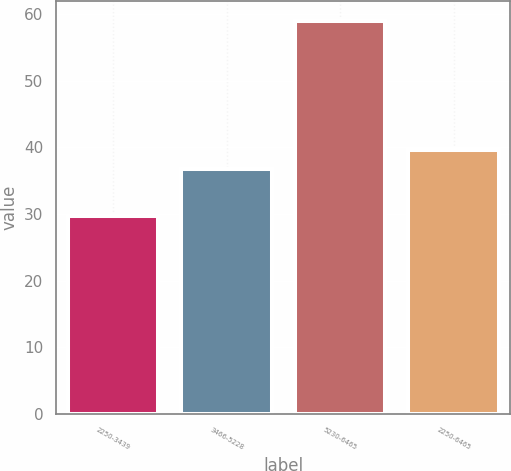Convert chart to OTSL. <chart><loc_0><loc_0><loc_500><loc_500><bar_chart><fcel>2250-3439<fcel>3466-5228<fcel>5230-6465<fcel>2250-6465<nl><fcel>29.64<fcel>36.68<fcel>58.98<fcel>39.61<nl></chart> 